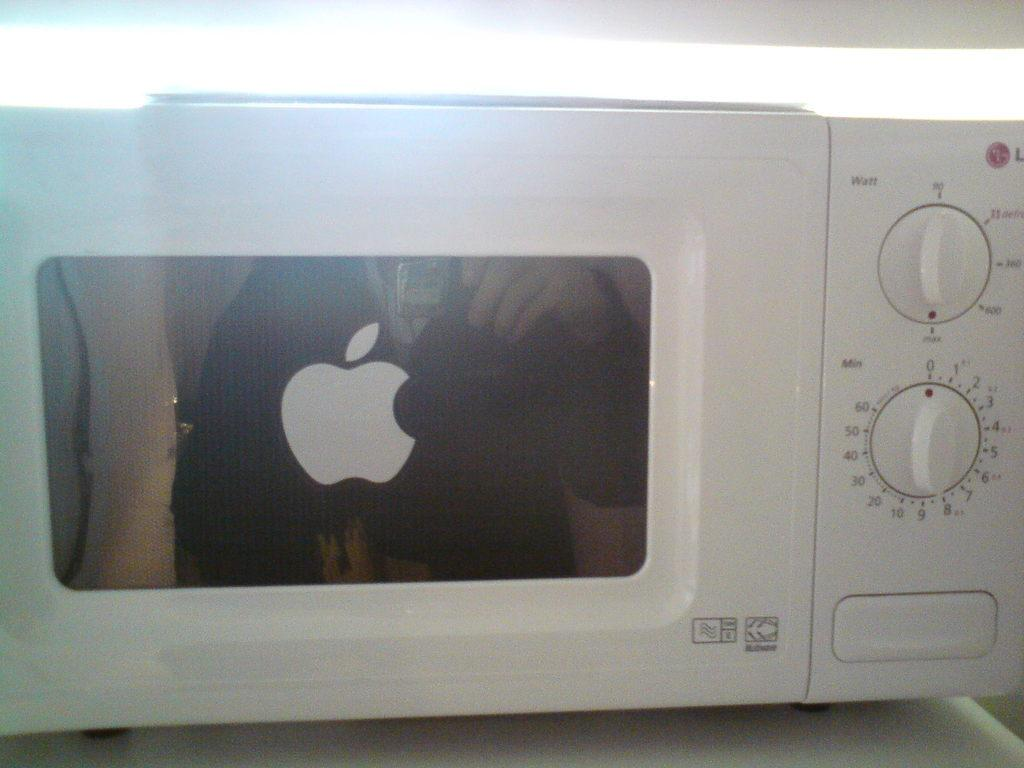<image>
Offer a succinct explanation of the picture presented. A microwave has a timer dial that goes up to 60 minutes and has an Apple logo on the door. 